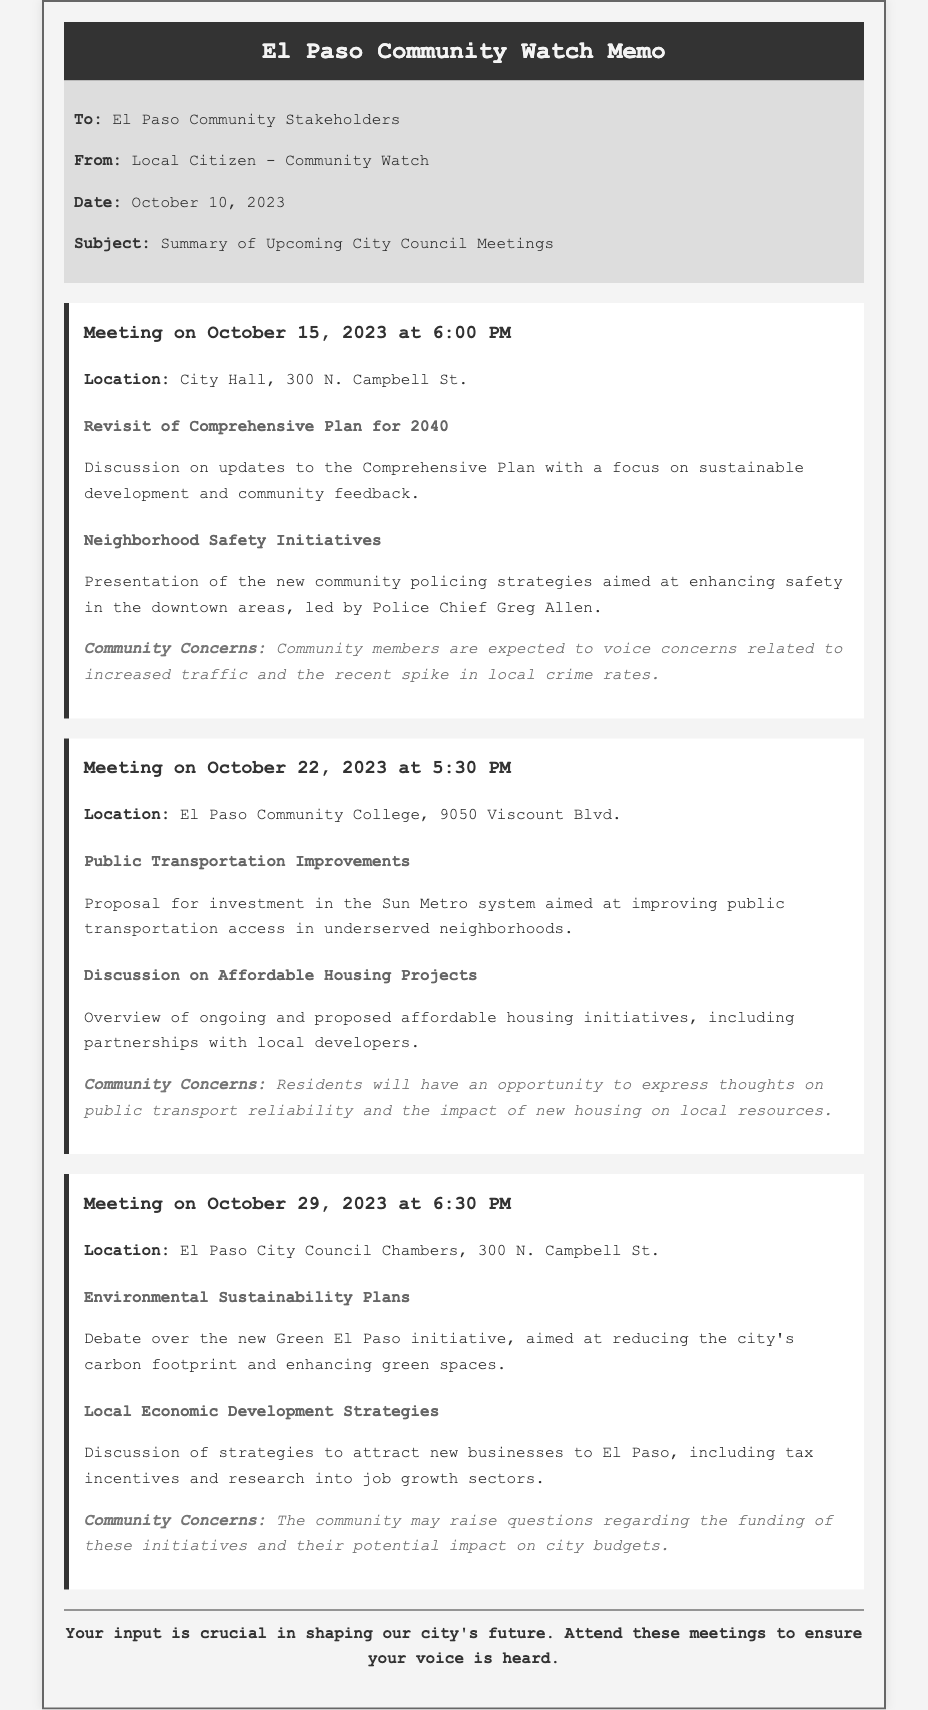What is the date of the first meeting? The date of the first meeting is explicitly stated in the document as October 15, 2023.
Answer: October 15, 2023 Who is presenting the neighborhood safety initiatives? The document mentions that the presentation will be led by Police Chief Greg Allen, highlighting his involvement.
Answer: Police Chief Greg Allen What is the location of the second meeting? The document provides the precise location for the second meeting as El Paso Community College, 9050 Viscount Blvd.
Answer: El Paso Community College, 9050 Viscount Blvd What is one of the community concerns regarding public transportation? The document specifies that residents can express thoughts on public transport reliability, indicating a specific area of concern.
Answer: Public transport reliability What initiative is being debated in the meeting on October 29? The document outlines that the debate at the meeting on October 29 will focus on the Green El Paso initiative.
Answer: Green El Paso initiative How many meetings are summarized in the document? The document lists three separate meetings with distinct dates, thus giving a total count of meetings.
Answer: Three What is the time for the meeting on October 22? The document clearly indicates that the meeting on October 22 will begin at 5:30 PM.
Answer: 5:30 PM What is one topic discussed at the last meeting? The document cites local economic development strategies as one of the topics discussed in the last meeting.
Answer: Local economic development strategies What is the purpose of the memo? The document states that the purpose is to summarize upcoming city council meetings related to community concerns and local development projects.
Answer: Summary of upcoming city council meetings 